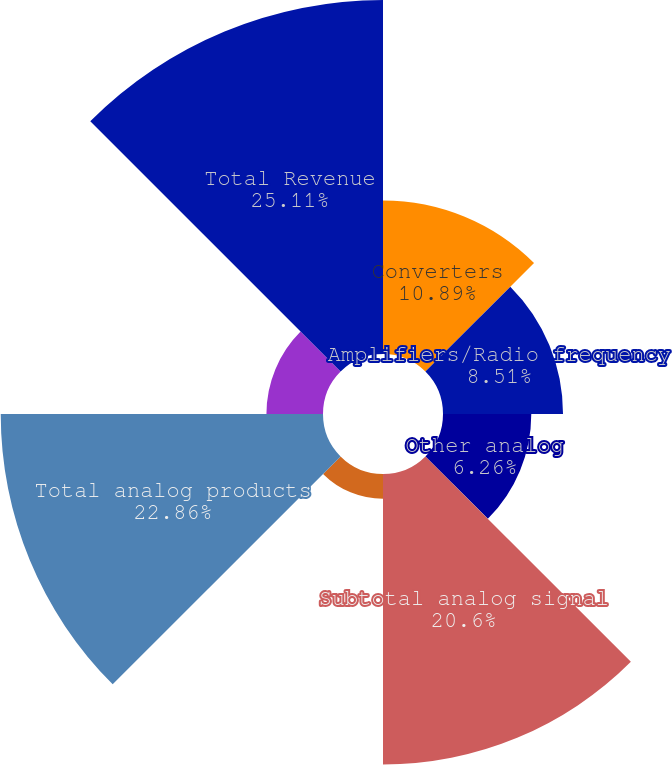Convert chart. <chart><loc_0><loc_0><loc_500><loc_500><pie_chart><fcel>Converters<fcel>Amplifiers/Radio frequency<fcel>Other analog<fcel>Subtotal analog signal<fcel>Power management & reference<fcel>Total analog products<fcel>Digital signal processing<fcel>Total Revenue<nl><fcel>10.89%<fcel>8.51%<fcel>6.26%<fcel>20.6%<fcel>1.76%<fcel>22.85%<fcel>4.01%<fcel>25.1%<nl></chart> 